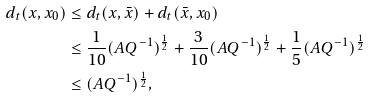<formula> <loc_0><loc_0><loc_500><loc_500>d _ { t } ( { x } , x _ { 0 } ) & \leq d _ { t } ( x , \bar { x } ) + d _ { t } ( \bar { x } , x _ { 0 } ) \\ & \leq \frac { 1 } { 1 0 } ( A Q ^ { - 1 } ) ^ { \frac { 1 } { 2 } } + \frac { 3 } { 1 0 } ( A Q ^ { - 1 } ) ^ { \frac { 1 } { 2 } } + \frac { 1 } { 5 } ( A Q ^ { - 1 } ) ^ { \frac { 1 } { 2 } } \\ & \leq ( A Q ^ { - 1 } ) ^ { \frac { 1 } { 2 } } ,</formula> 